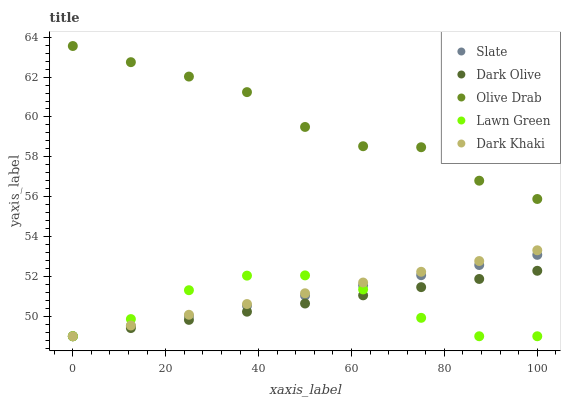Does Lawn Green have the minimum area under the curve?
Answer yes or no. Yes. Does Olive Drab have the maximum area under the curve?
Answer yes or no. Yes. Does Slate have the minimum area under the curve?
Answer yes or no. No. Does Slate have the maximum area under the curve?
Answer yes or no. No. Is Dark Olive the smoothest?
Answer yes or no. Yes. Is Olive Drab the roughest?
Answer yes or no. Yes. Is Lawn Green the smoothest?
Answer yes or no. No. Is Lawn Green the roughest?
Answer yes or no. No. Does Dark Khaki have the lowest value?
Answer yes or no. Yes. Does Olive Drab have the lowest value?
Answer yes or no. No. Does Olive Drab have the highest value?
Answer yes or no. Yes. Does Slate have the highest value?
Answer yes or no. No. Is Dark Khaki less than Olive Drab?
Answer yes or no. Yes. Is Olive Drab greater than Dark Olive?
Answer yes or no. Yes. Does Slate intersect Lawn Green?
Answer yes or no. Yes. Is Slate less than Lawn Green?
Answer yes or no. No. Is Slate greater than Lawn Green?
Answer yes or no. No. Does Dark Khaki intersect Olive Drab?
Answer yes or no. No. 